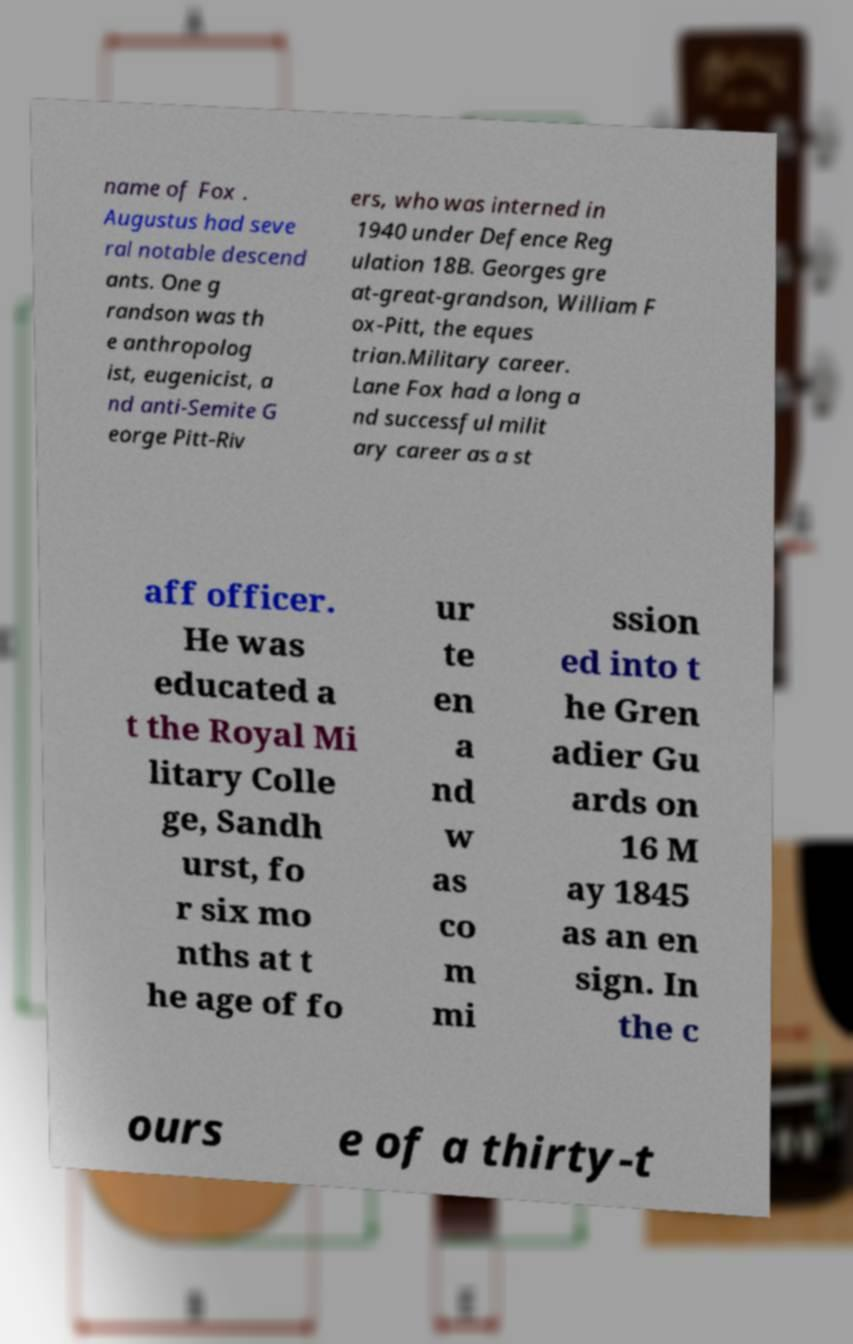For documentation purposes, I need the text within this image transcribed. Could you provide that? name of Fox . Augustus had seve ral notable descend ants. One g randson was th e anthropolog ist, eugenicist, a nd anti-Semite G eorge Pitt-Riv ers, who was interned in 1940 under Defence Reg ulation 18B. Georges gre at-great-grandson, William F ox-Pitt, the eques trian.Military career. Lane Fox had a long a nd successful milit ary career as a st aff officer. He was educated a t the Royal Mi litary Colle ge, Sandh urst, fo r six mo nths at t he age of fo ur te en a nd w as co m mi ssion ed into t he Gren adier Gu ards on 16 M ay 1845 as an en sign. In the c ours e of a thirty-t 